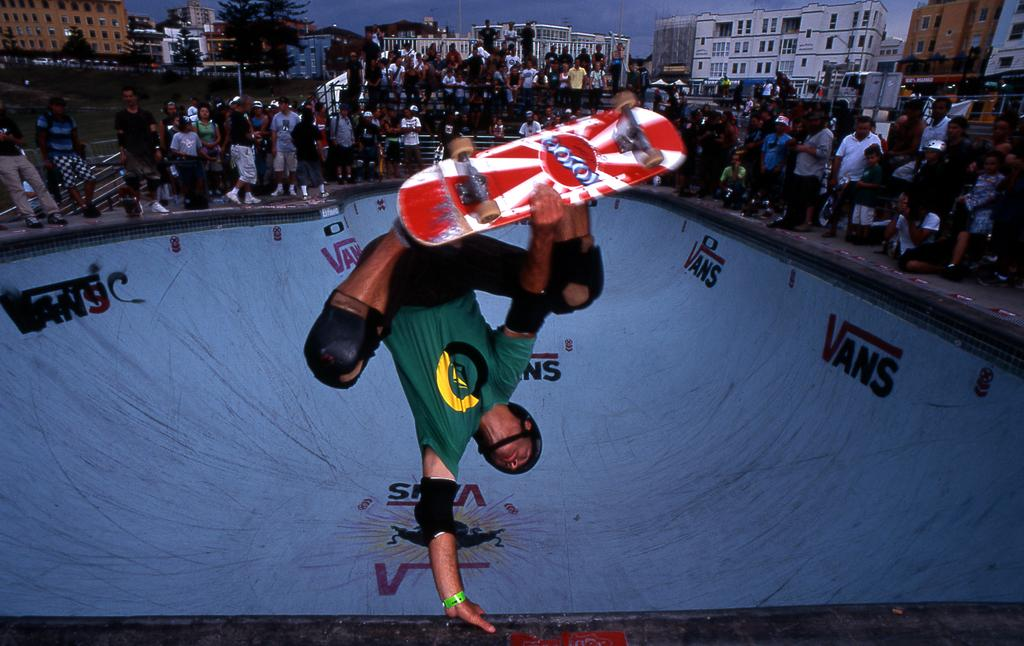What is the main subject of the image? There is a person riding a skateboard in the image. What is the person on while riding the skateboard? The person is on a surface. What can be seen in the background of the image? There are people, trees, buildings, and the sky visible in the background of the image. What type of leather is being discussed by the people in the background of the image? There is no discussion about leather in the image, nor are there any visible leather items. 